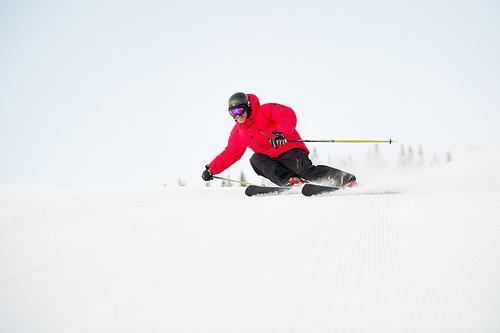How many people are in the photo?
Give a very brief answer. 1. 